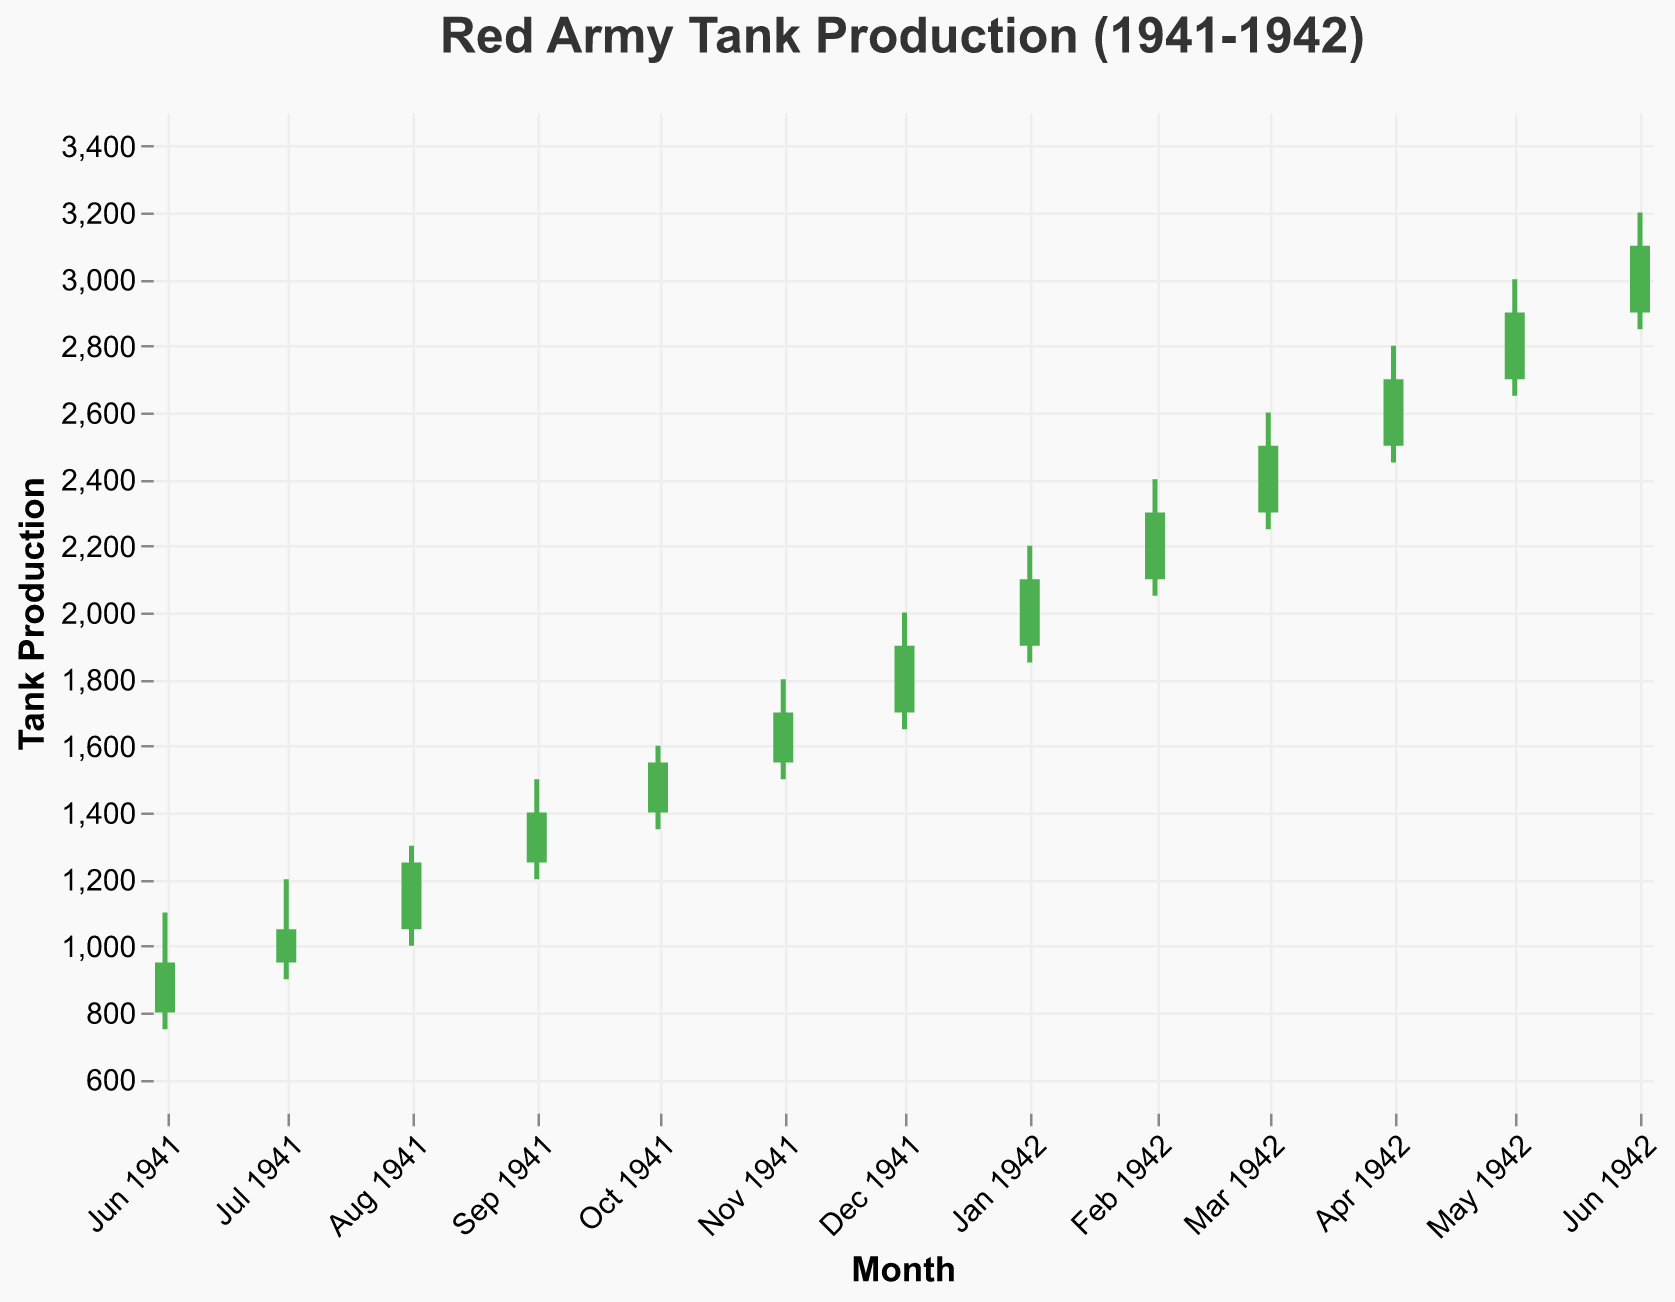What is the title of the figure? The title of the figure is displayed prominently at the top of the visualization. Reading the title is a simple task as it provides a summary of the chart’s content.
Answer: Red Army Tank Production (1941-1942) When did tank production first exceed 1000 units in a month? By comparing the values on the vertical axis for each month, we find the first month where the production (close value) surpassed 1000. This happens in July 1941.
Answer: July 1941 What months saw a decline in tank production from open to close values? To identify the months with a decline, we check each month's open and close values. If the close value is less than the open value, it signifies a decline. June 1941 and July 1941 are such months.
Answer: June 1941, July 1941 Which month had the highest high value, and what was it? By reviewing the high values on the y-axis for each month, we find that December 1941 had the highest high value of 2000 units.
Answer: December 1941, 2000 units How much did the tank production increase from the end of 1941 to June 1942? The close value at the end of 1941 is December, which is 1900 units. The close value in June 1942 is 3100 units. The increase is 3100 - 1900 = 1200 units.
Answer: 1200 units What is the average high value for the entire period from June 1941 to June 1942? To calculate the average high value, sum all the high values and divide by the number of months (13). The sum of high values is 1100 + 1200 + 1300 + 1500 + 1600 + 1800 + 2000 + 2200 + 2400 + 2600 + 2800 + 3000 + 3200 = 27600. The average is then 27600 / 13 = 2123 units.
Answer: 2123 units In which month did the low value first reach 2000 units? To find this, we look at the low values for each month. The first occurrence is in February 1942 with a low value of 2050 units.
Answer: February 1942 How many months showed an increase in tank production from open to close values? By reviewing the open and close values for each month, we count the instances where the close value is greater than the open value. There are 11 such months.
Answer: 11 months 